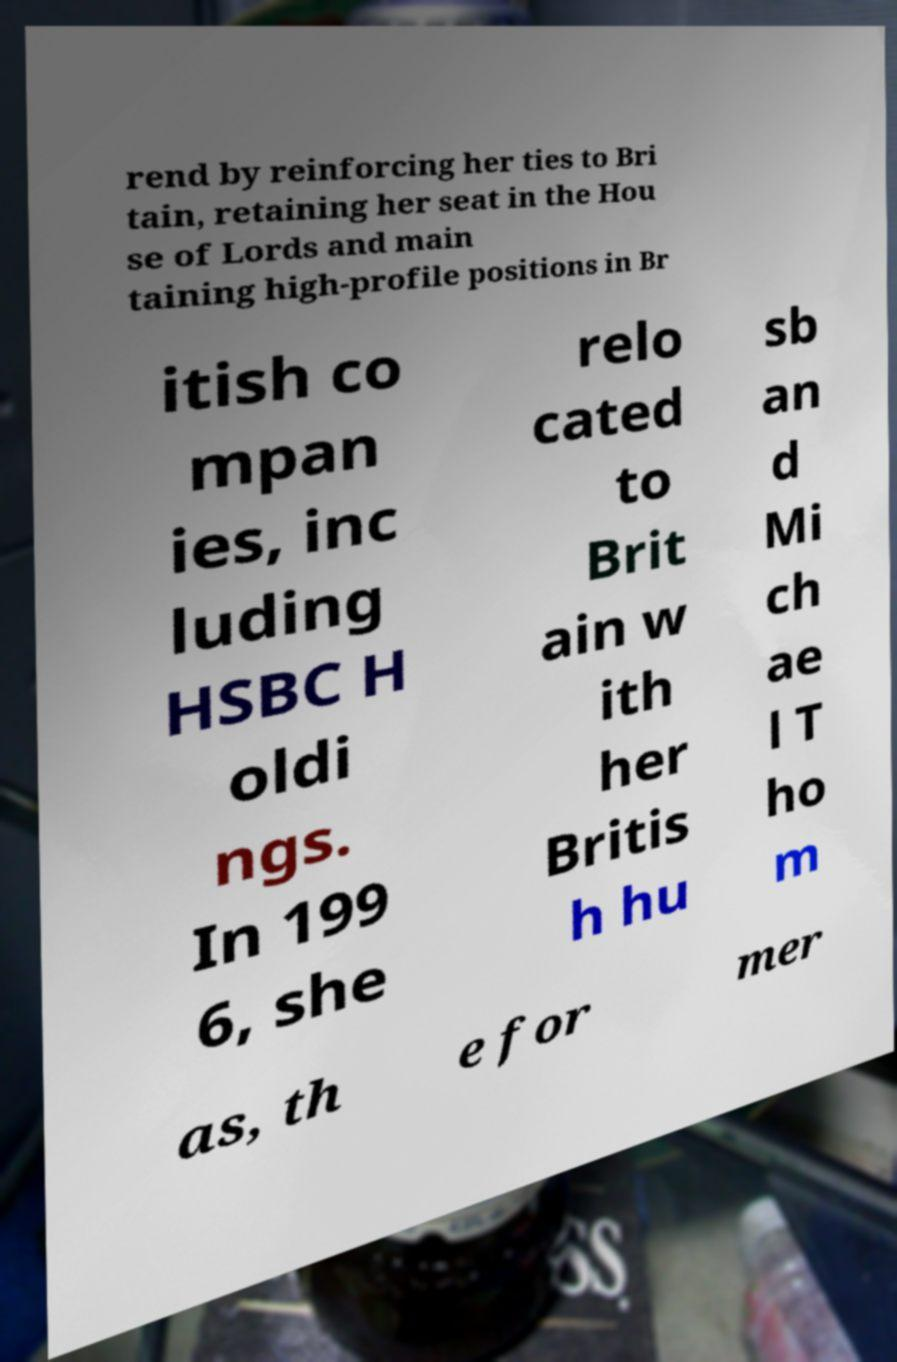For documentation purposes, I need the text within this image transcribed. Could you provide that? rend by reinforcing her ties to Bri tain, retaining her seat in the Hou se of Lords and main taining high-profile positions in Br itish co mpan ies, inc luding HSBC H oldi ngs. In 199 6, she relo cated to Brit ain w ith her Britis h hu sb an d Mi ch ae l T ho m as, th e for mer 